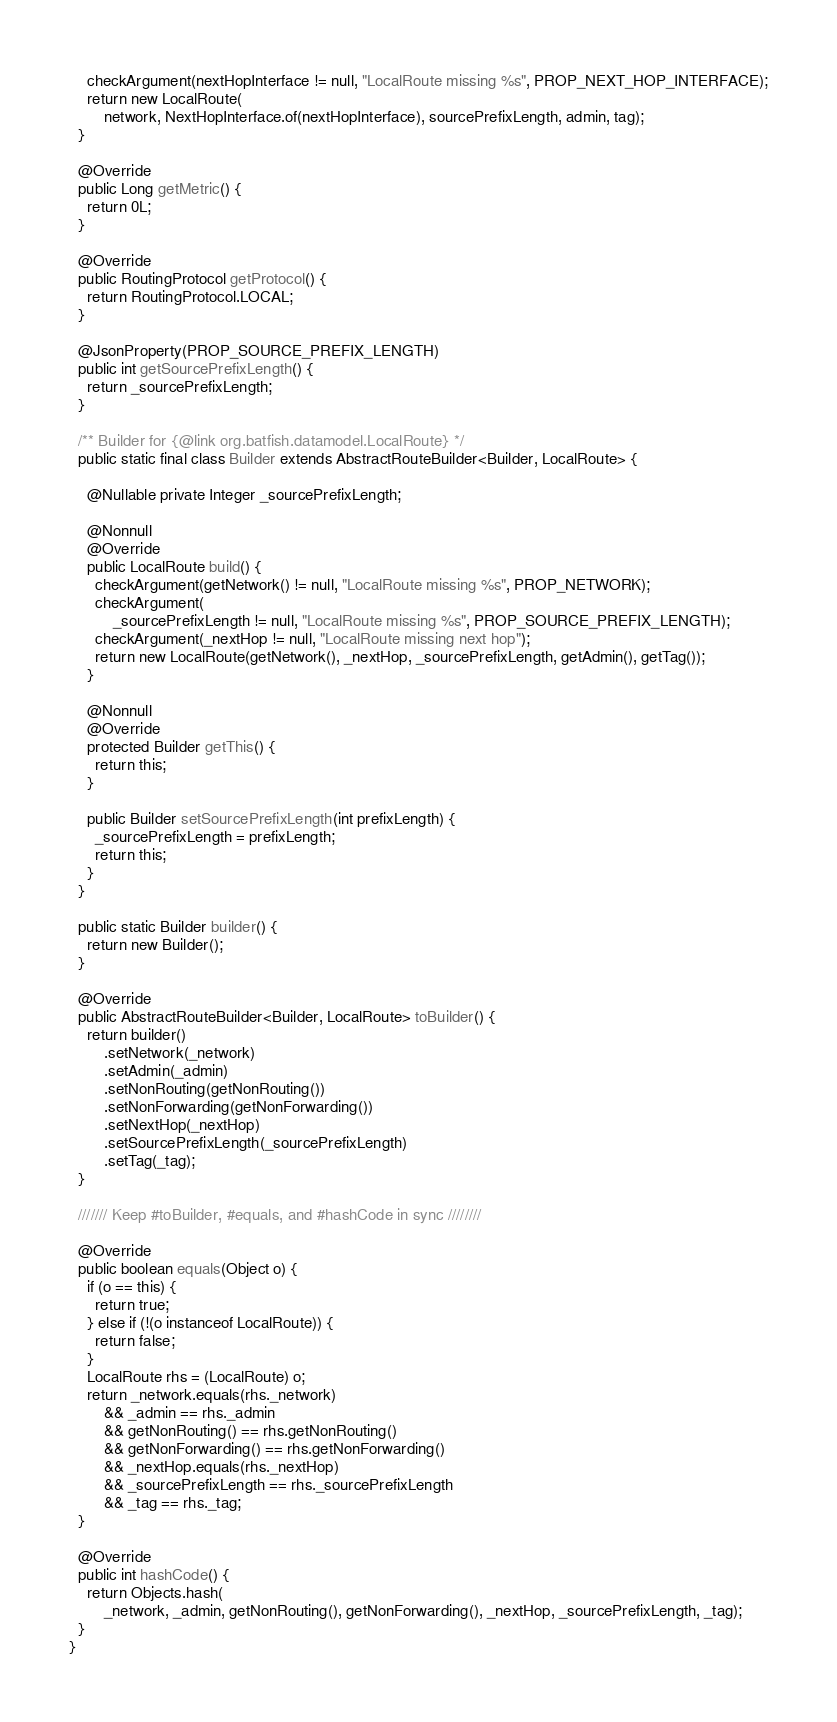<code> <loc_0><loc_0><loc_500><loc_500><_Java_>    checkArgument(nextHopInterface != null, "LocalRoute missing %s", PROP_NEXT_HOP_INTERFACE);
    return new LocalRoute(
        network, NextHopInterface.of(nextHopInterface), sourcePrefixLength, admin, tag);
  }

  @Override
  public Long getMetric() {
    return 0L;
  }

  @Override
  public RoutingProtocol getProtocol() {
    return RoutingProtocol.LOCAL;
  }

  @JsonProperty(PROP_SOURCE_PREFIX_LENGTH)
  public int getSourcePrefixLength() {
    return _sourcePrefixLength;
  }

  /** Builder for {@link org.batfish.datamodel.LocalRoute} */
  public static final class Builder extends AbstractRouteBuilder<Builder, LocalRoute> {

    @Nullable private Integer _sourcePrefixLength;

    @Nonnull
    @Override
    public LocalRoute build() {
      checkArgument(getNetwork() != null, "LocalRoute missing %s", PROP_NETWORK);
      checkArgument(
          _sourcePrefixLength != null, "LocalRoute missing %s", PROP_SOURCE_PREFIX_LENGTH);
      checkArgument(_nextHop != null, "LocalRoute missing next hop");
      return new LocalRoute(getNetwork(), _nextHop, _sourcePrefixLength, getAdmin(), getTag());
    }

    @Nonnull
    @Override
    protected Builder getThis() {
      return this;
    }

    public Builder setSourcePrefixLength(int prefixLength) {
      _sourcePrefixLength = prefixLength;
      return this;
    }
  }

  public static Builder builder() {
    return new Builder();
  }

  @Override
  public AbstractRouteBuilder<Builder, LocalRoute> toBuilder() {
    return builder()
        .setNetwork(_network)
        .setAdmin(_admin)
        .setNonRouting(getNonRouting())
        .setNonForwarding(getNonForwarding())
        .setNextHop(_nextHop)
        .setSourcePrefixLength(_sourcePrefixLength)
        .setTag(_tag);
  }

  /////// Keep #toBuilder, #equals, and #hashCode in sync ////////

  @Override
  public boolean equals(Object o) {
    if (o == this) {
      return true;
    } else if (!(o instanceof LocalRoute)) {
      return false;
    }
    LocalRoute rhs = (LocalRoute) o;
    return _network.equals(rhs._network)
        && _admin == rhs._admin
        && getNonRouting() == rhs.getNonRouting()
        && getNonForwarding() == rhs.getNonForwarding()
        && _nextHop.equals(rhs._nextHop)
        && _sourcePrefixLength == rhs._sourcePrefixLength
        && _tag == rhs._tag;
  }

  @Override
  public int hashCode() {
    return Objects.hash(
        _network, _admin, getNonRouting(), getNonForwarding(), _nextHop, _sourcePrefixLength, _tag);
  }
}
</code> 